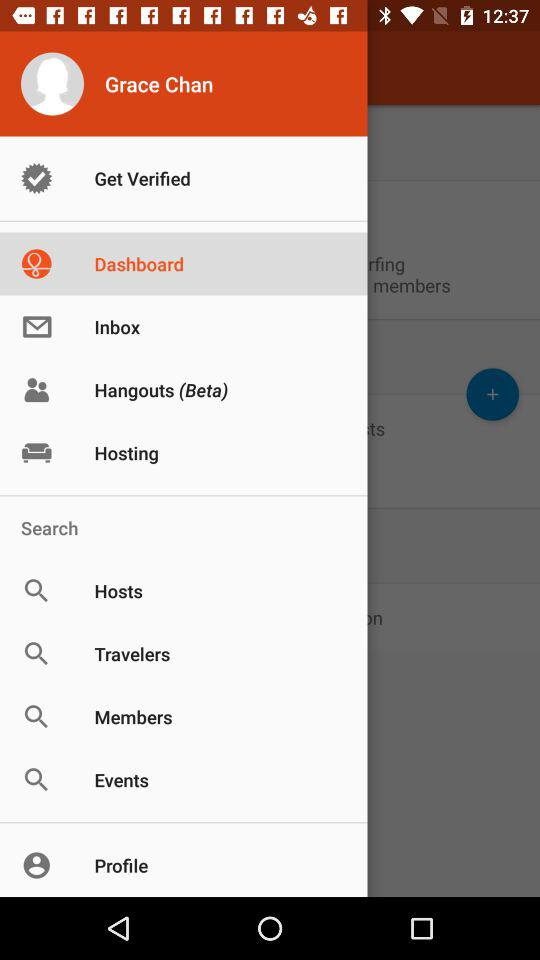Which item is selected in the menu? The selected item is "Dashboard". 